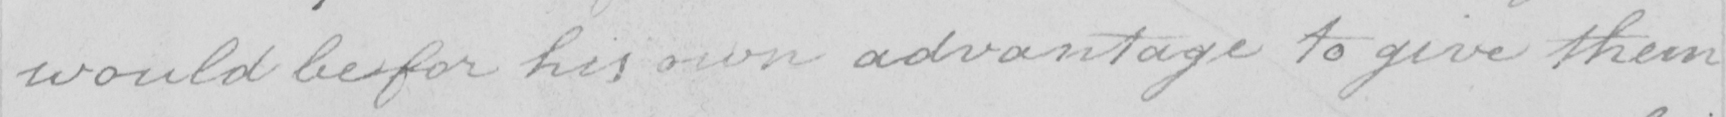Please transcribe the handwritten text in this image. would be for his own advantage to give them 